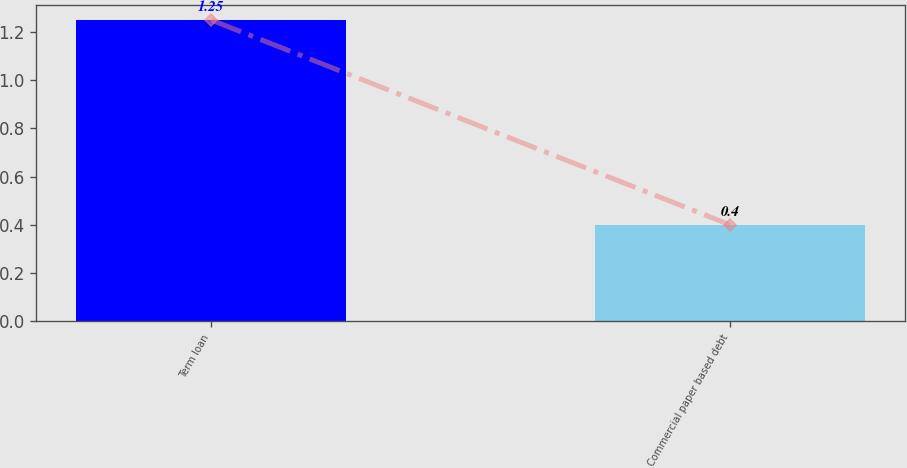Convert chart. <chart><loc_0><loc_0><loc_500><loc_500><bar_chart><fcel>Term loan<fcel>Commercial paper based debt<nl><fcel>1.25<fcel>0.4<nl></chart> 